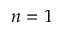<formula> <loc_0><loc_0><loc_500><loc_500>n = 1</formula> 